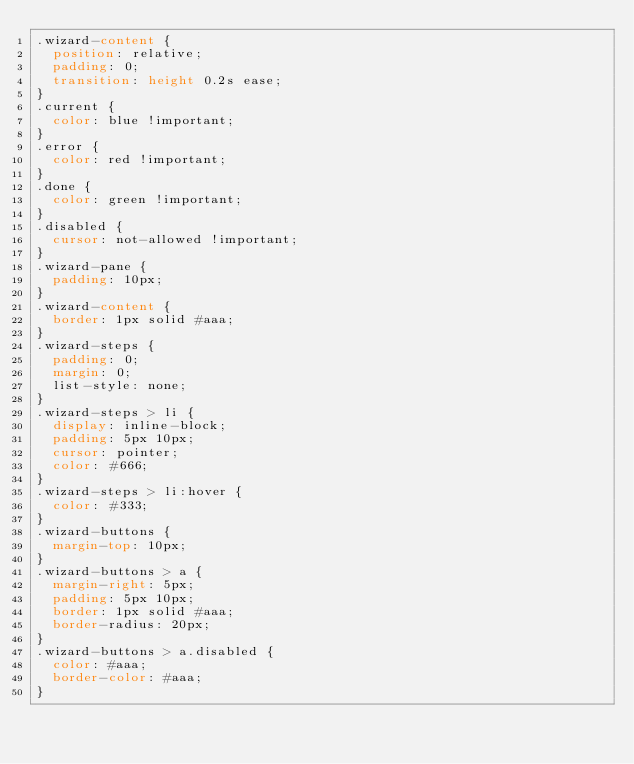<code> <loc_0><loc_0><loc_500><loc_500><_CSS_>.wizard-content {
  position: relative;
  padding: 0;
  transition: height 0.2s ease;
}
.current {
  color: blue !important;
}
.error {
  color: red !important;
}
.done {
  color: green !important;
}
.disabled {
  cursor: not-allowed !important;
}
.wizard-pane {
  padding: 10px;
}
.wizard-content {
  border: 1px solid #aaa;
}
.wizard-steps {
  padding: 0;
  margin: 0;
  list-style: none;
}
.wizard-steps > li {
  display: inline-block;
  padding: 5px 10px;
  cursor: pointer;
  color: #666;
}
.wizard-steps > li:hover {
  color: #333;
}
.wizard-buttons {
  margin-top: 10px;
}
.wizard-buttons > a {
  margin-right: 5px;
  padding: 5px 10px;
  border: 1px solid #aaa;
  border-radius: 20px;
}
.wizard-buttons > a.disabled {
  color: #aaa;
  border-color: #aaa;
}
</code> 